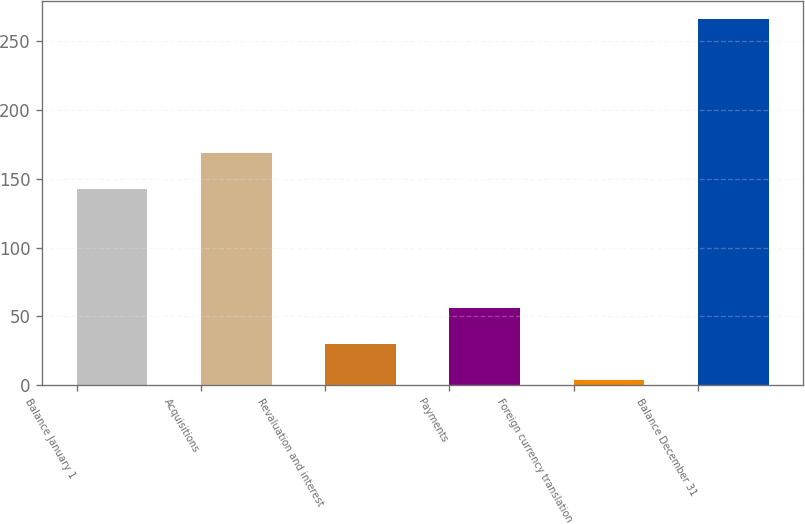Convert chart to OTSL. <chart><loc_0><loc_0><loc_500><loc_500><bar_chart><fcel>Balance January 1<fcel>Acquisitions<fcel>Revaluation and interest<fcel>Payments<fcel>Foreign currency translation<fcel>Balance December 31<nl><fcel>142.6<fcel>168.84<fcel>30.04<fcel>56.28<fcel>3.8<fcel>266.2<nl></chart> 